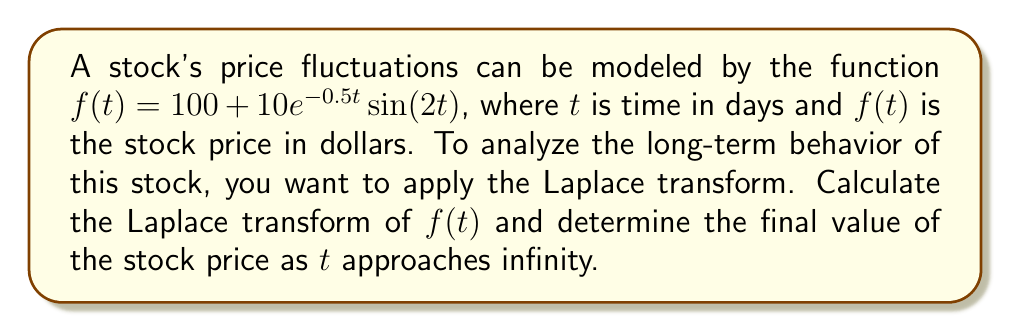What is the answer to this math problem? To solve this problem, we'll follow these steps:

1) First, let's recall the Laplace transform of $f(t)$:

   $\mathcal{L}\{f(t)\} = F(s) = \int_0^\infty f(t)e^{-st}dt$

2) Our function $f(t)$ has two parts: a constant term and a product of exponential and sine functions. We can use linearity and known Laplace transform pairs:

   $f(t) = 100 + 10e^{-0.5t}\sin(2t)$

3) For the constant term:
   
   $\mathcal{L}\{100\} = \frac{100}{s}$

4) For the $10e^{-0.5t}\sin(2t)$ term, we can use the Laplace transform of $e^{at}\sin(bt)$:

   $\mathcal{L}\{e^{at}\sin(bt)\} = \frac{b}{(s-a)^2 + b^2}$

   In our case, $a = -0.5$ and $b = 2$

5) Putting it all together:

   $F(s) = \frac{100}{s} + 10 \cdot \frac{2}{(s+0.5)^2 + 2^2}$

   $F(s) = \frac{100}{s} + \frac{20}{(s+0.5)^2 + 4}$

6) To find the final value of $f(t)$ as $t$ approaches infinity, we can use the Final Value Theorem:

   $\lim_{t \to \infty} f(t) = \lim_{s \to 0} sF(s)$

7) Applying this to our $F(s)$:

   $\lim_{s \to 0} s(\frac{100}{s} + \frac{20}{(s+0.5)^2 + 4})$

   $= \lim_{s \to 0} (100 + \frac{20s}{(s+0.5)^2 + 4})$

   $= 100 + 0 = 100$

Therefore, the stock price will stabilize at $100 in the long term.
Answer: The Laplace transform of $f(t)$ is $F(s) = \frac{100}{s} + \frac{20}{(s+0.5)^2 + 4}$, and the final value of the stock price as $t$ approaches infinity is $100. 